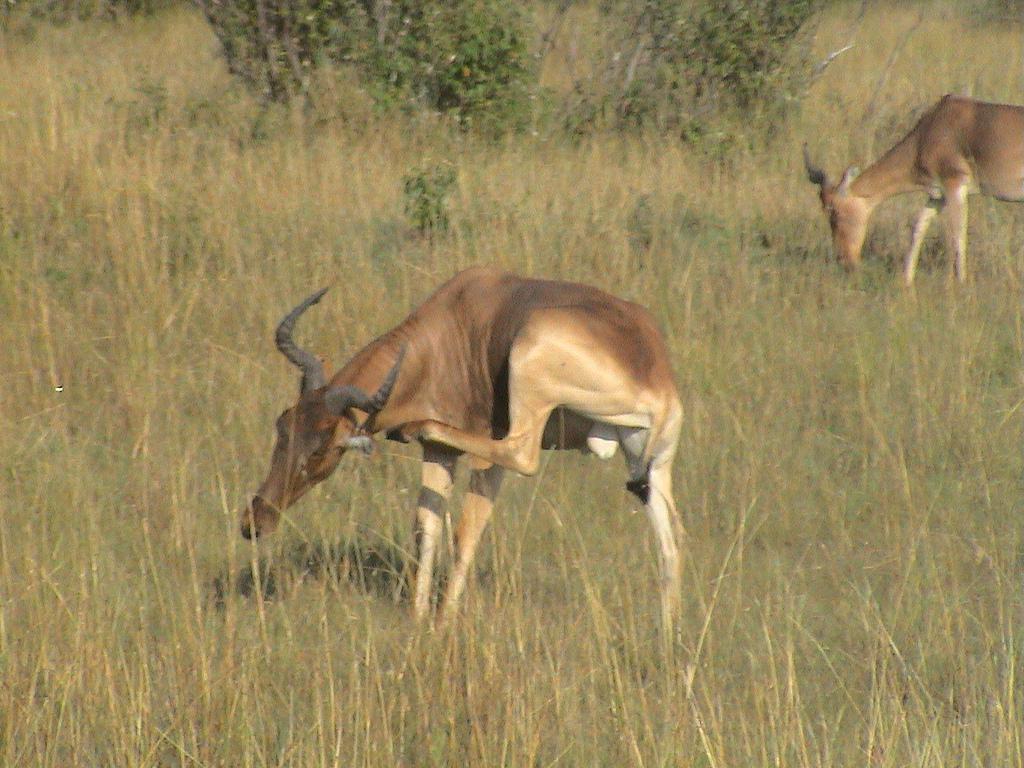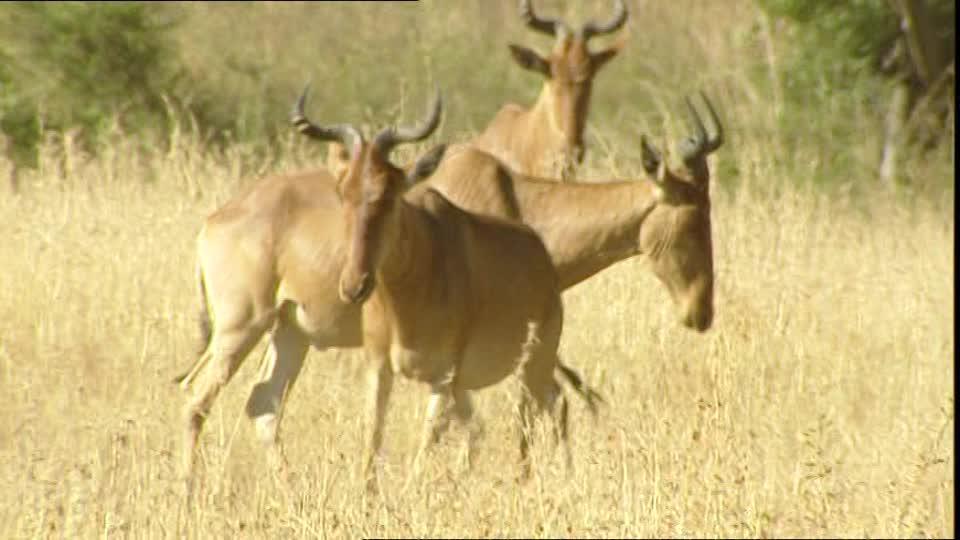The first image is the image on the left, the second image is the image on the right. Evaluate the accuracy of this statement regarding the images: "Each image contains multiple horned animals, and one image includes horned animals facing opposite directions and overlapping.". Is it true? Answer yes or no. Yes. The first image is the image on the left, the second image is the image on the right. For the images displayed, is the sentence "There are exactly two living animals." factually correct? Answer yes or no. No. 